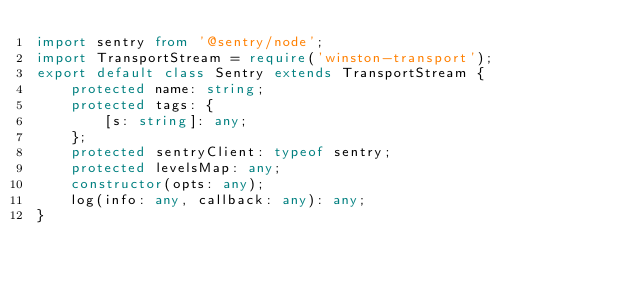<code> <loc_0><loc_0><loc_500><loc_500><_TypeScript_>import sentry from '@sentry/node';
import TransportStream = require('winston-transport');
export default class Sentry extends TransportStream {
    protected name: string;
    protected tags: {
        [s: string]: any;
    };
    protected sentryClient: typeof sentry;
    protected levelsMap: any;
    constructor(opts: any);
    log(info: any, callback: any): any;
}
</code> 